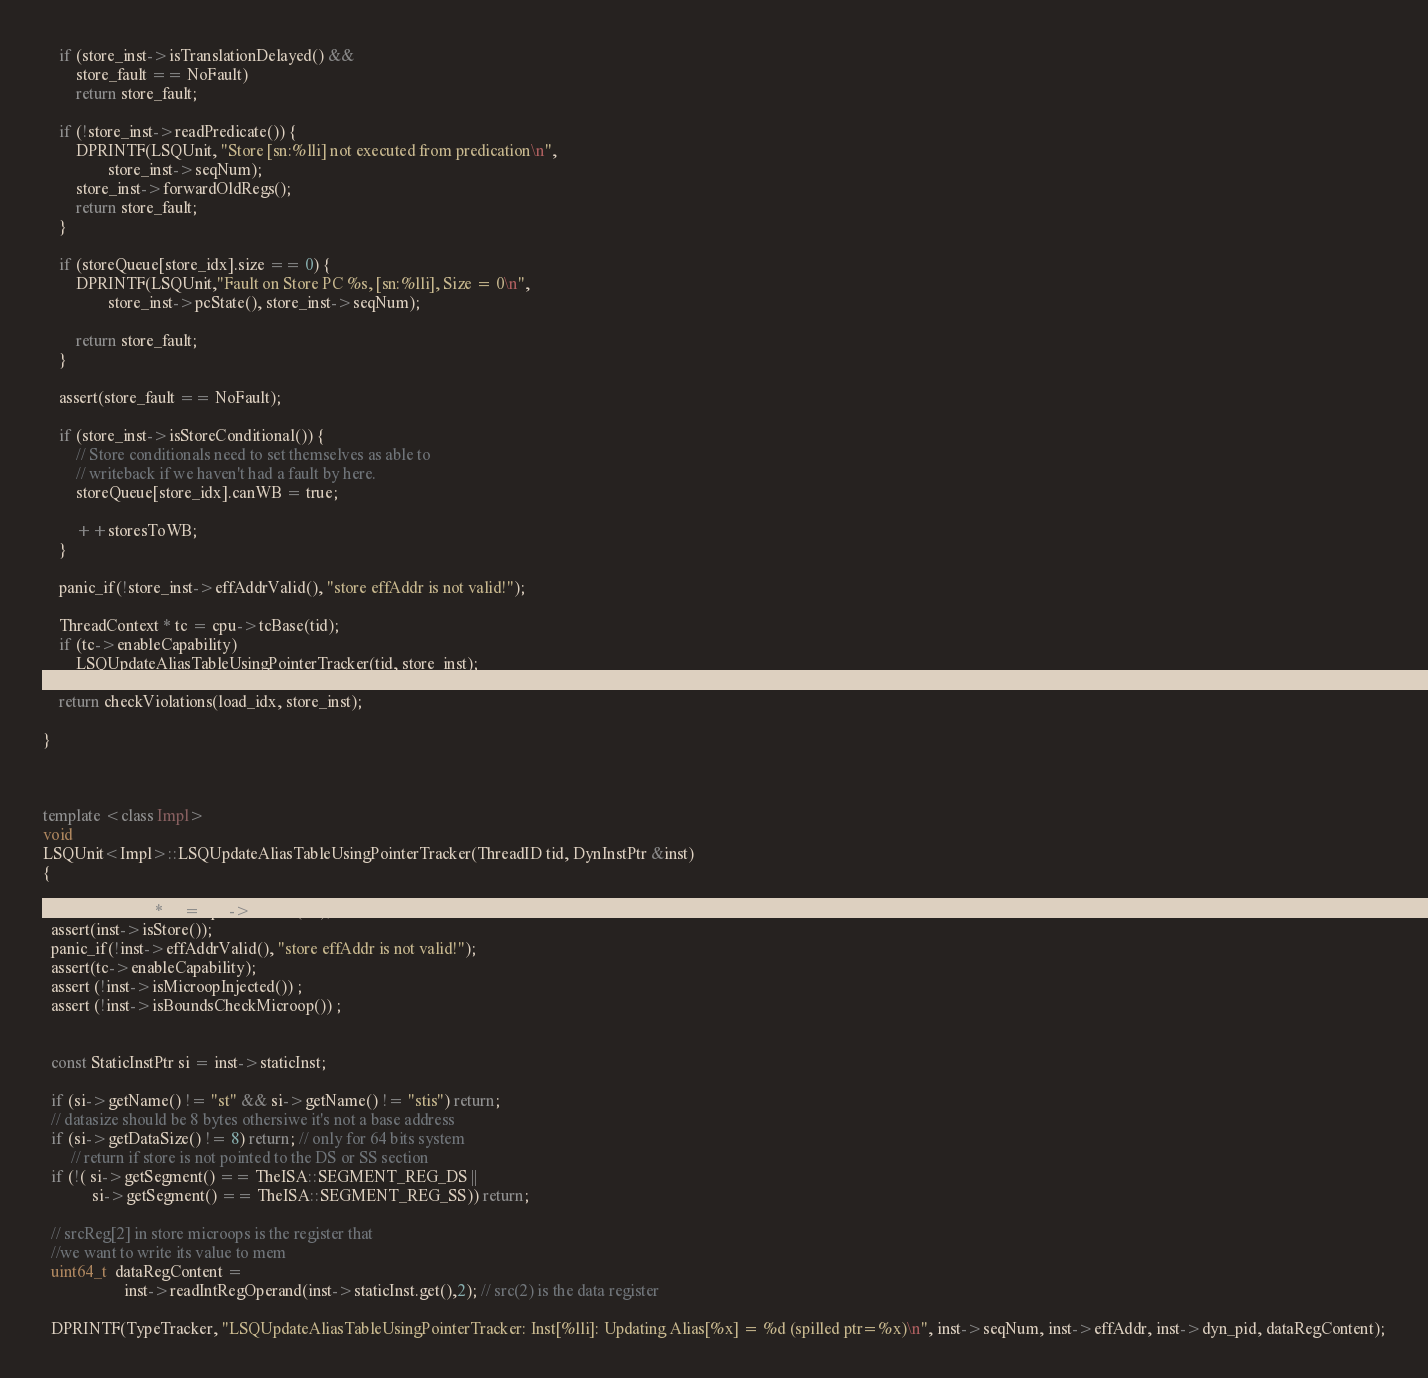Convert code to text. <code><loc_0><loc_0><loc_500><loc_500><_C++_>
    if (store_inst->isTranslationDelayed() &&
        store_fault == NoFault)
        return store_fault;

    if (!store_inst->readPredicate()) {
        DPRINTF(LSQUnit, "Store [sn:%lli] not executed from predication\n",
                store_inst->seqNum);
        store_inst->forwardOldRegs();
        return store_fault;
    }

    if (storeQueue[store_idx].size == 0) {
        DPRINTF(LSQUnit,"Fault on Store PC %s, [sn:%lli], Size = 0\n",
                store_inst->pcState(), store_inst->seqNum);

        return store_fault;
    }

    assert(store_fault == NoFault);

    if (store_inst->isStoreConditional()) {
        // Store conditionals need to set themselves as able to
        // writeback if we haven't had a fault by here.
        storeQueue[store_idx].canWB = true;

        ++storesToWB;
    }

    panic_if(!store_inst->effAddrValid(), "store effAddr is not valid!");

    ThreadContext * tc = cpu->tcBase(tid);
    if (tc->enableCapability) 
        LSQUpdateAliasTableUsingPointerTracker(tid, store_inst);
    
    return checkViolations(load_idx, store_inst);

}



template <class Impl>
void
LSQUnit<Impl>::LSQUpdateAliasTableUsingPointerTracker(ThreadID tid, DynInstPtr &inst)
{
  
  ThreadContext * tc = cpu->tcBase(tid); 
  assert(inst->isStore());
  panic_if(!inst->effAddrValid(), "store effAddr is not valid!");
  assert(tc->enableCapability);
  assert (!inst->isMicroopInjected()) ;
  assert (!inst->isBoundsCheckMicroop()) ;


  const StaticInstPtr si = inst->staticInst;
  
  if (si->getName() != "st" && si->getName() != "stis") return;
  // datasize should be 8 bytes othersiwe it's not a base address
  if (si->getDataSize() != 8) return; // only for 64 bits system
       // return if store is not pointed to the DS or SS section
  if (!( si->getSegment() == TheISA::SEGMENT_REG_DS ||
            si->getSegment() == TheISA::SEGMENT_REG_SS)) return;

  // srcReg[2] in store microops is the register that
  //we want to write its value to mem
  uint64_t  dataRegContent =
                    inst->readIntRegOperand(inst->staticInst.get(),2); // src(2) is the data register

  DPRINTF(TypeTracker, "LSQUpdateAliasTableUsingPointerTracker: Inst[%lli]: Updating Alias[%x] = %d (spilled ptr=%x)\n", inst->seqNum, inst->effAddr, inst->dyn_pid, dataRegContent);</code> 